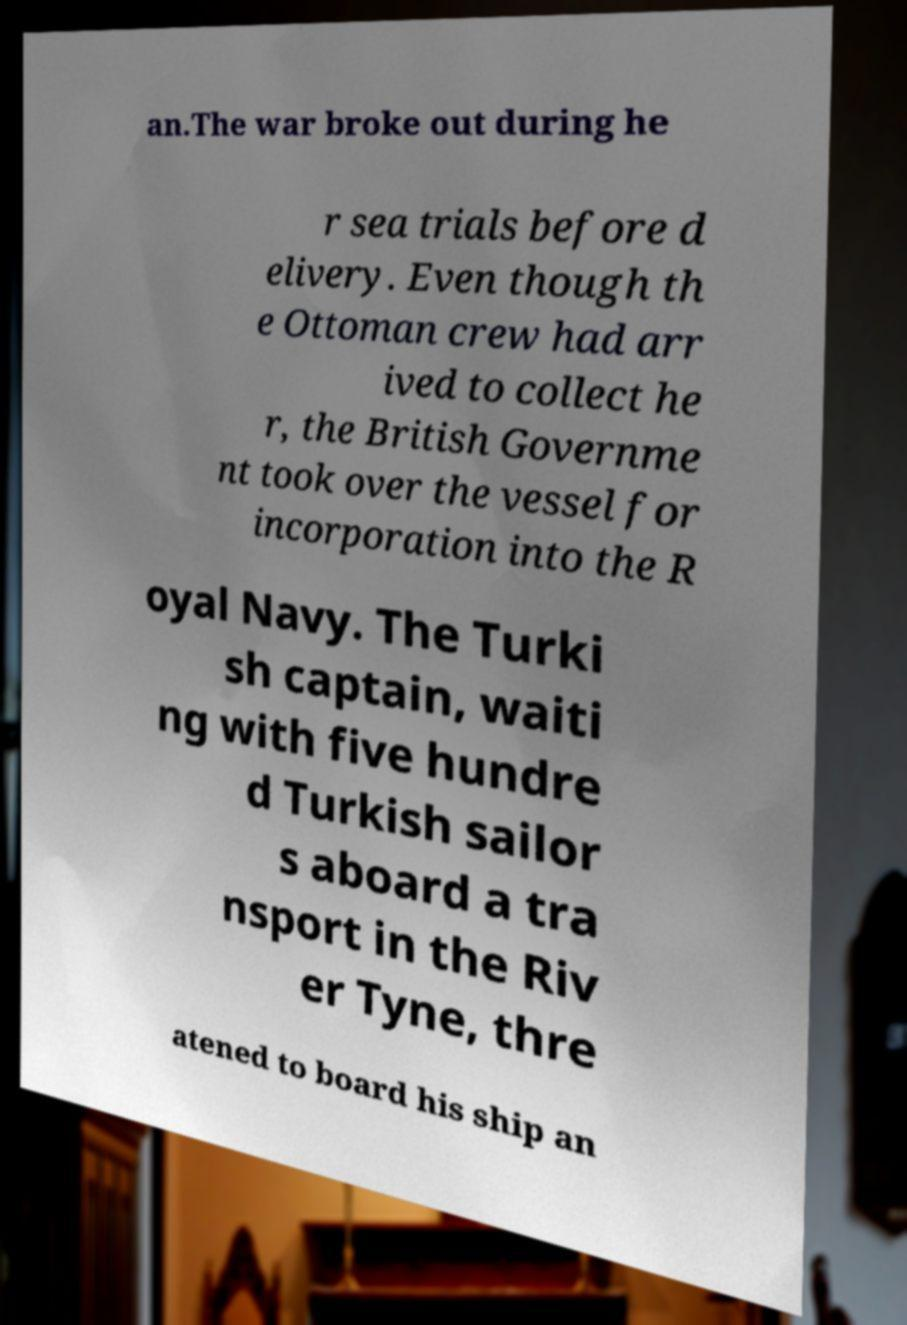Could you extract and type out the text from this image? an.The war broke out during he r sea trials before d elivery. Even though th e Ottoman crew had arr ived to collect he r, the British Governme nt took over the vessel for incorporation into the R oyal Navy. The Turki sh captain, waiti ng with five hundre d Turkish sailor s aboard a tra nsport in the Riv er Tyne, thre atened to board his ship an 